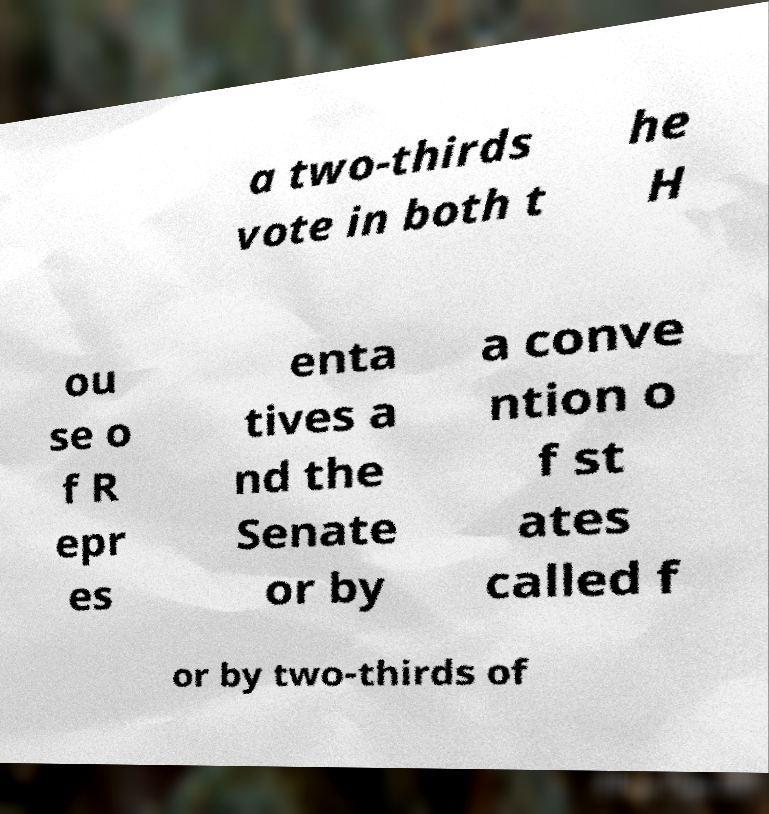What messages or text are displayed in this image? I need them in a readable, typed format. a two-thirds vote in both t he H ou se o f R epr es enta tives a nd the Senate or by a conve ntion o f st ates called f or by two-thirds of 